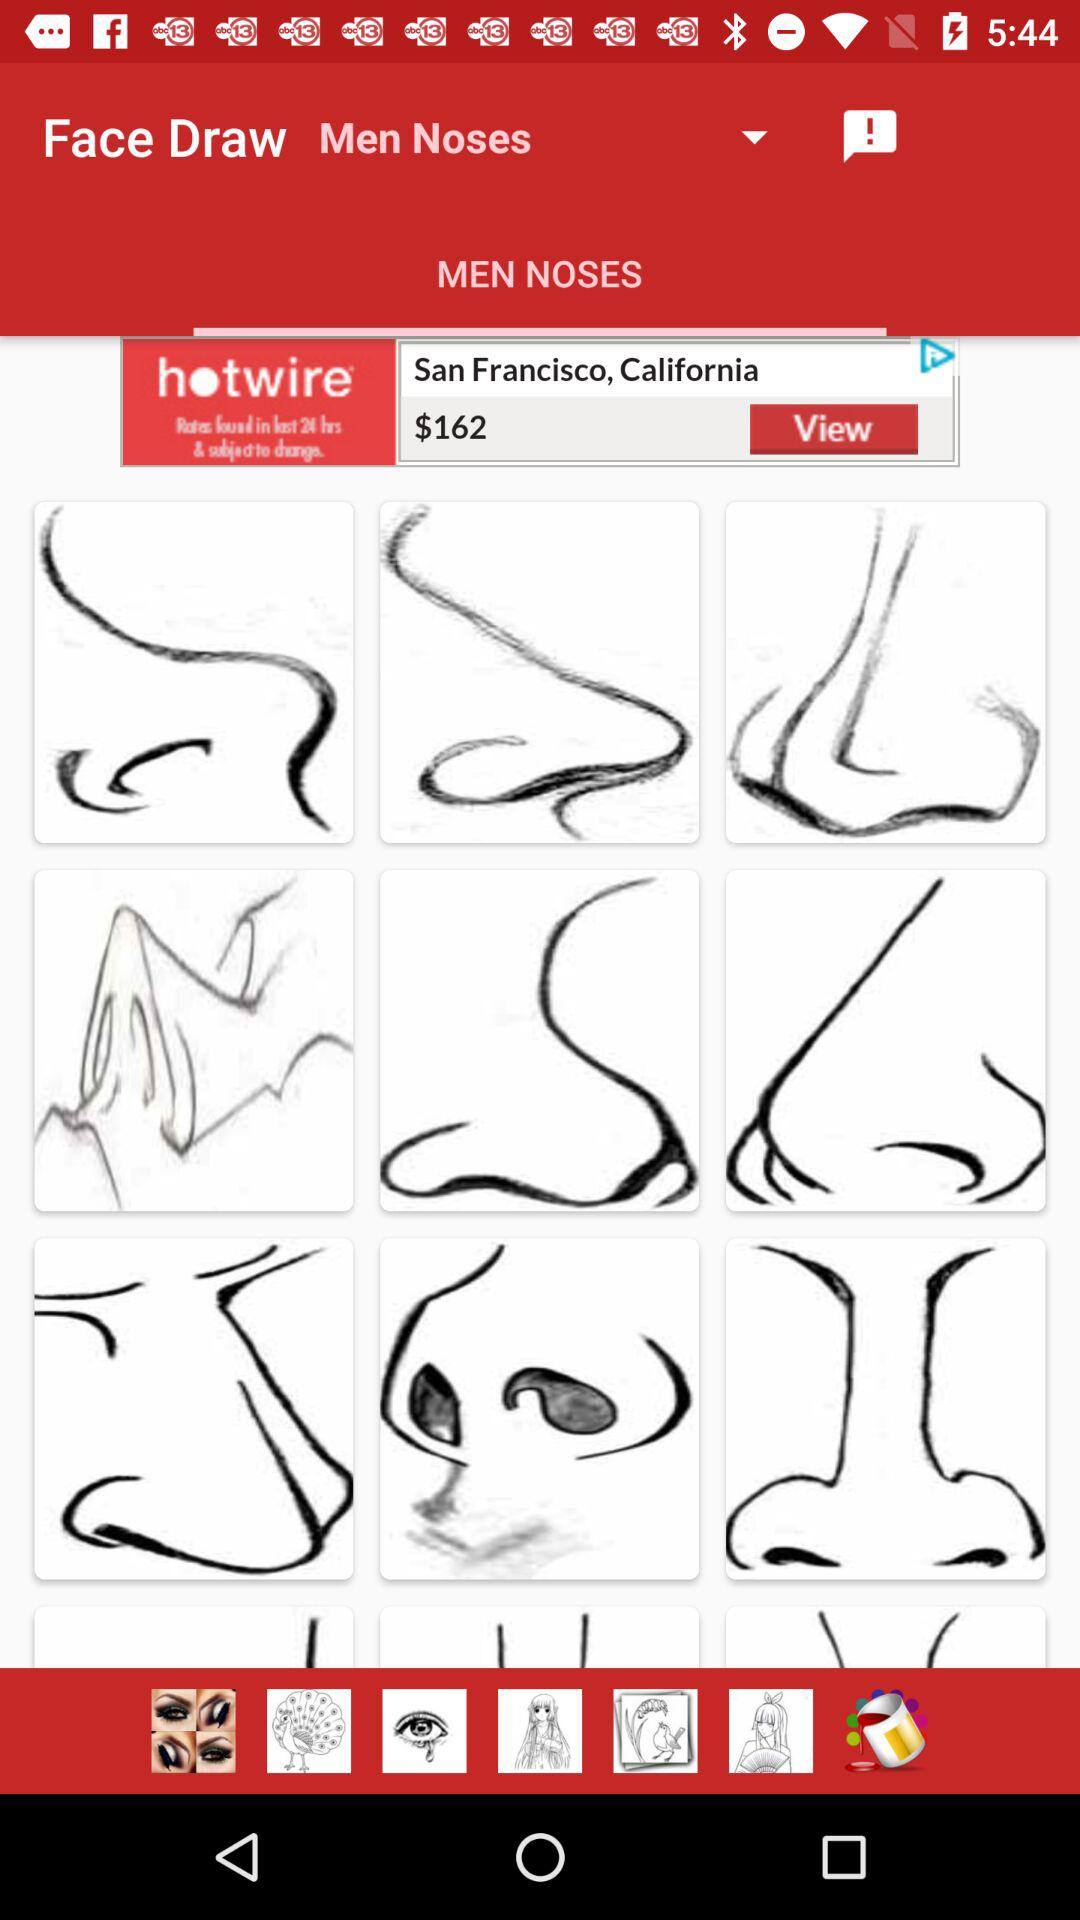For which gender are noses drawn? The noses are drawn for men. 